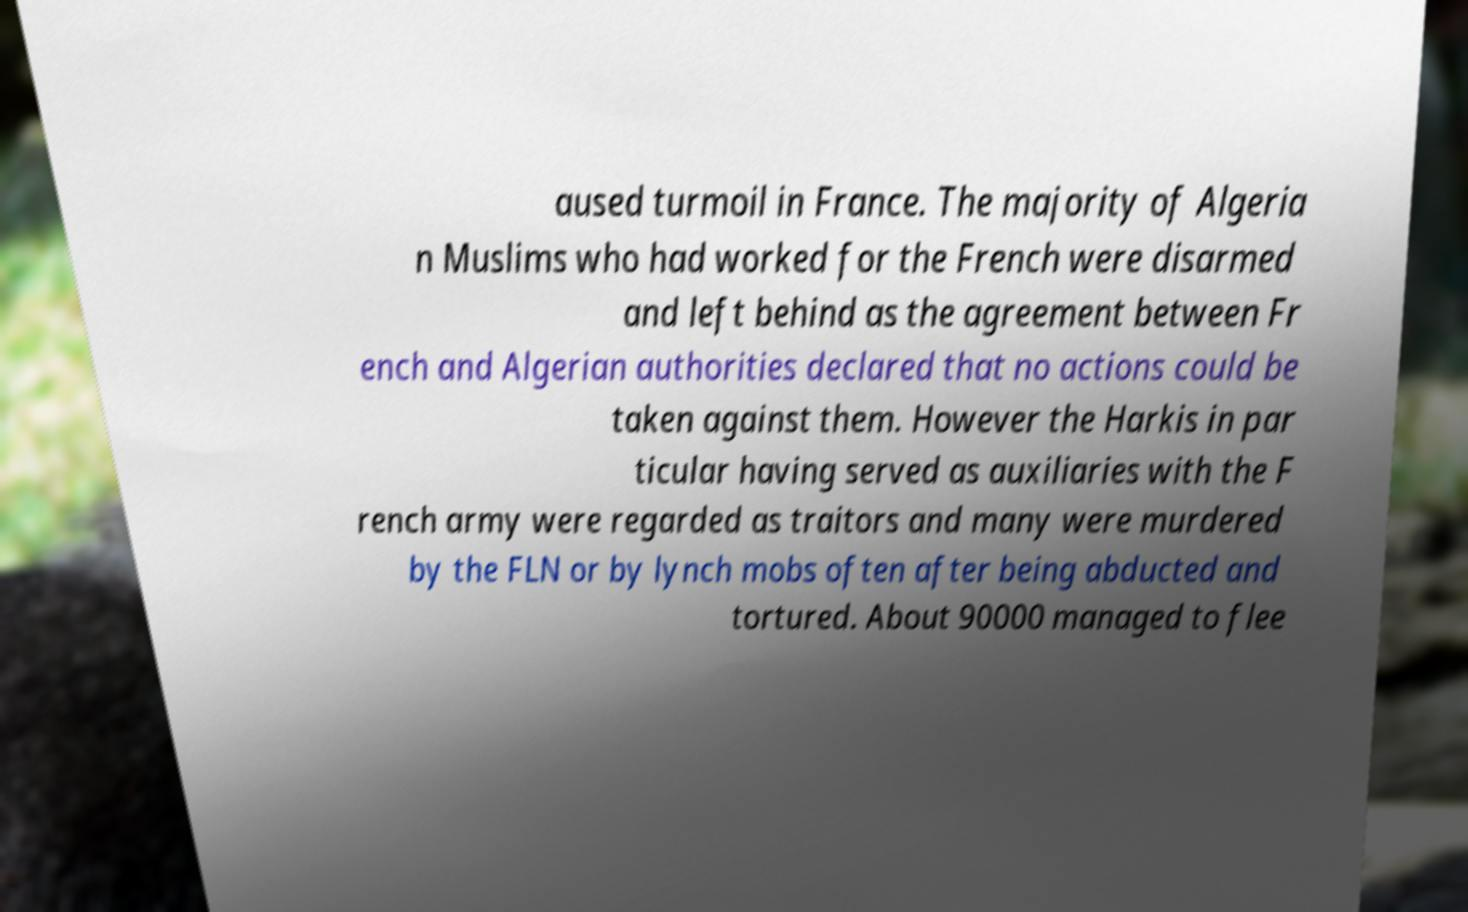Could you assist in decoding the text presented in this image and type it out clearly? aused turmoil in France. The majority of Algeria n Muslims who had worked for the French were disarmed and left behind as the agreement between Fr ench and Algerian authorities declared that no actions could be taken against them. However the Harkis in par ticular having served as auxiliaries with the F rench army were regarded as traitors and many were murdered by the FLN or by lynch mobs often after being abducted and tortured. About 90000 managed to flee 